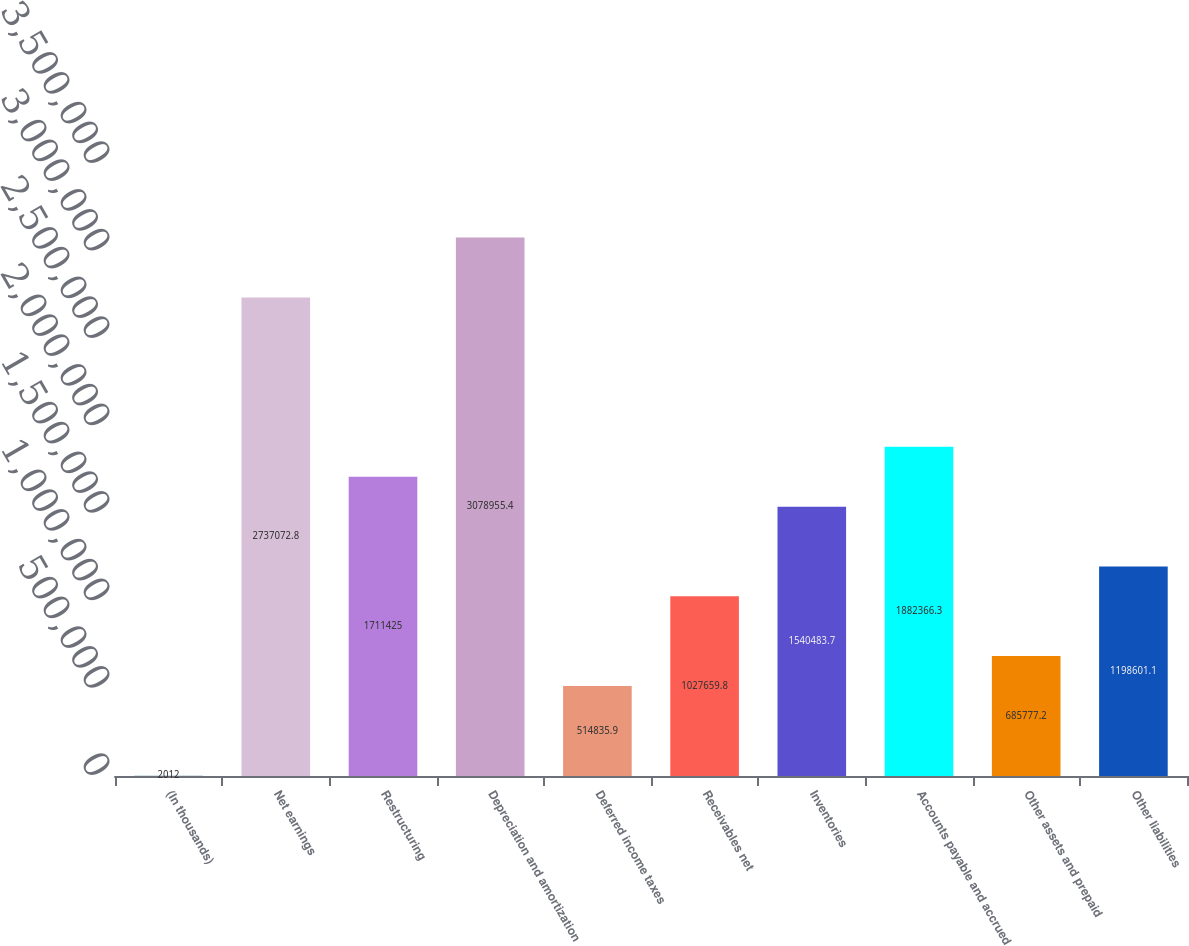Convert chart to OTSL. <chart><loc_0><loc_0><loc_500><loc_500><bar_chart><fcel>(In thousands)<fcel>Net earnings<fcel>Restructuring<fcel>Depreciation and amortization<fcel>Deferred income taxes<fcel>Receivables net<fcel>Inventories<fcel>Accounts payable and accrued<fcel>Other assets and prepaid<fcel>Other liabilities<nl><fcel>2012<fcel>2.73707e+06<fcel>1.71142e+06<fcel>3.07896e+06<fcel>514836<fcel>1.02766e+06<fcel>1.54048e+06<fcel>1.88237e+06<fcel>685777<fcel>1.1986e+06<nl></chart> 